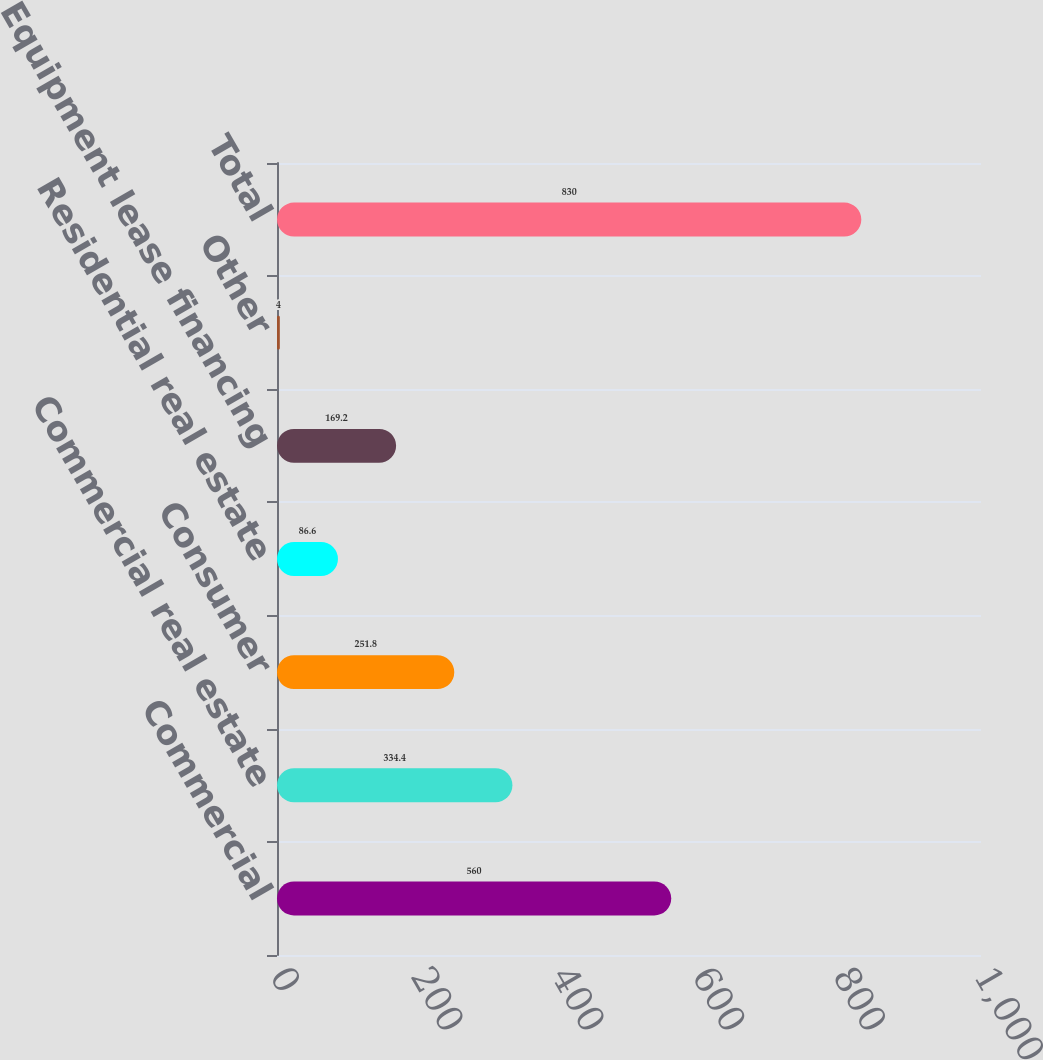<chart> <loc_0><loc_0><loc_500><loc_500><bar_chart><fcel>Commercial<fcel>Commercial real estate<fcel>Consumer<fcel>Residential real estate<fcel>Equipment lease financing<fcel>Other<fcel>Total<nl><fcel>560<fcel>334.4<fcel>251.8<fcel>86.6<fcel>169.2<fcel>4<fcel>830<nl></chart> 